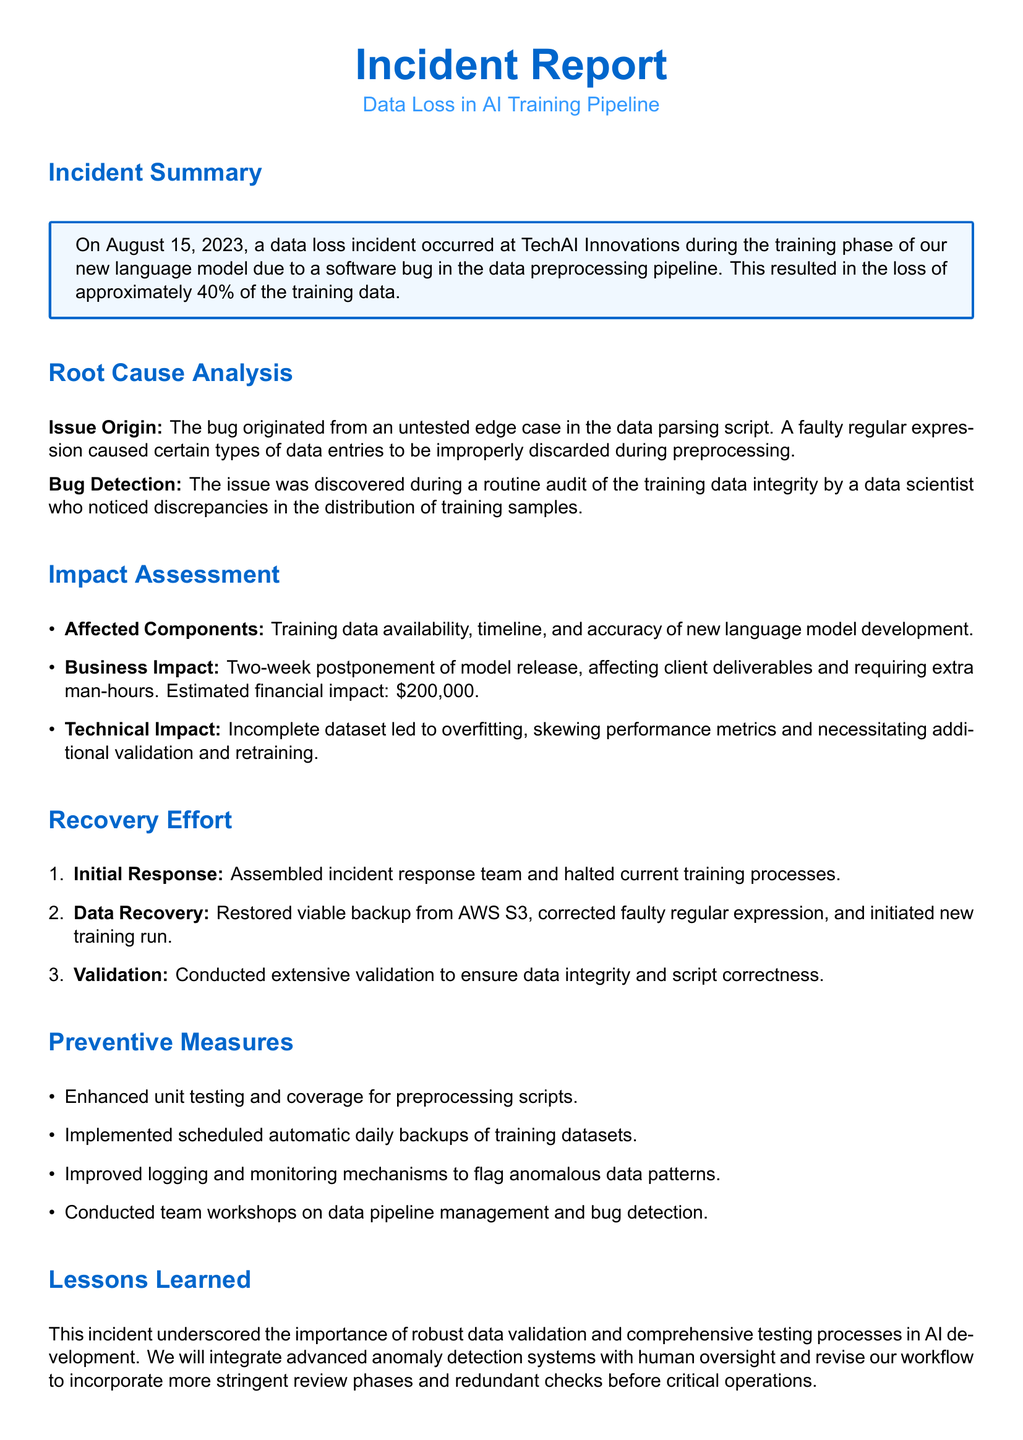What was the date of the incident? The incident occurred on August 15, 2023, as stated in the summary.
Answer: August 15, 2023 What percentage of the training data was lost? The report states that approximately 40% of the training data was lost.
Answer: 40% What was the estimated financial impact of the incident? The document mentions an estimated financial impact of $200,000.
Answer: $200,000 What caused the bug in the data preprocessing pipeline? The bug was due to a faulty regular expression in the data parsing script.
Answer: Faulty regular expression How long was the model release postponed? The incident resulted in a two-week postponement of the model release.
Answer: Two weeks What step was taken for data recovery? The viable backup was restored from AWS S3 as part of the recovery efforts.
Answer: AWS S3 What preventive measure was implemented regarding data backups? Scheduled automatic daily backups of training datasets were implemented.
Answer: Daily backups What was one of the lessons learned from this incident? The incident emphasized the importance of robust data validation and comprehensive testing processes.
Answer: Robust data validation What action was taken immediately after the incident? The initial response involved assembling an incident response team and halting current training processes.
Answer: Halted current training processes 